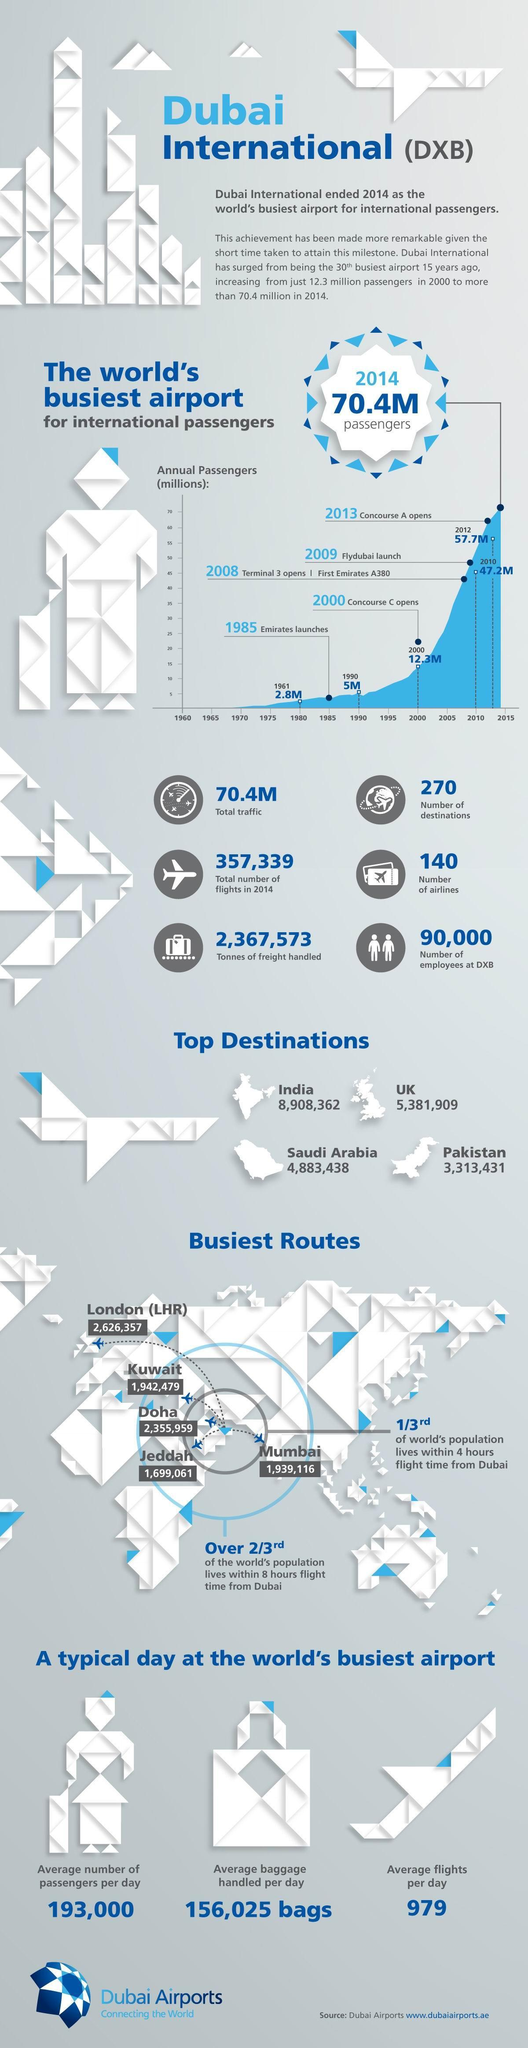What is the average number of passengers per day?
Answer the question with a short phrase. 193,000 What is the number of airlines? 140 What is the number of destinations? 270 What is the total number of flights in 2014? 357,339 